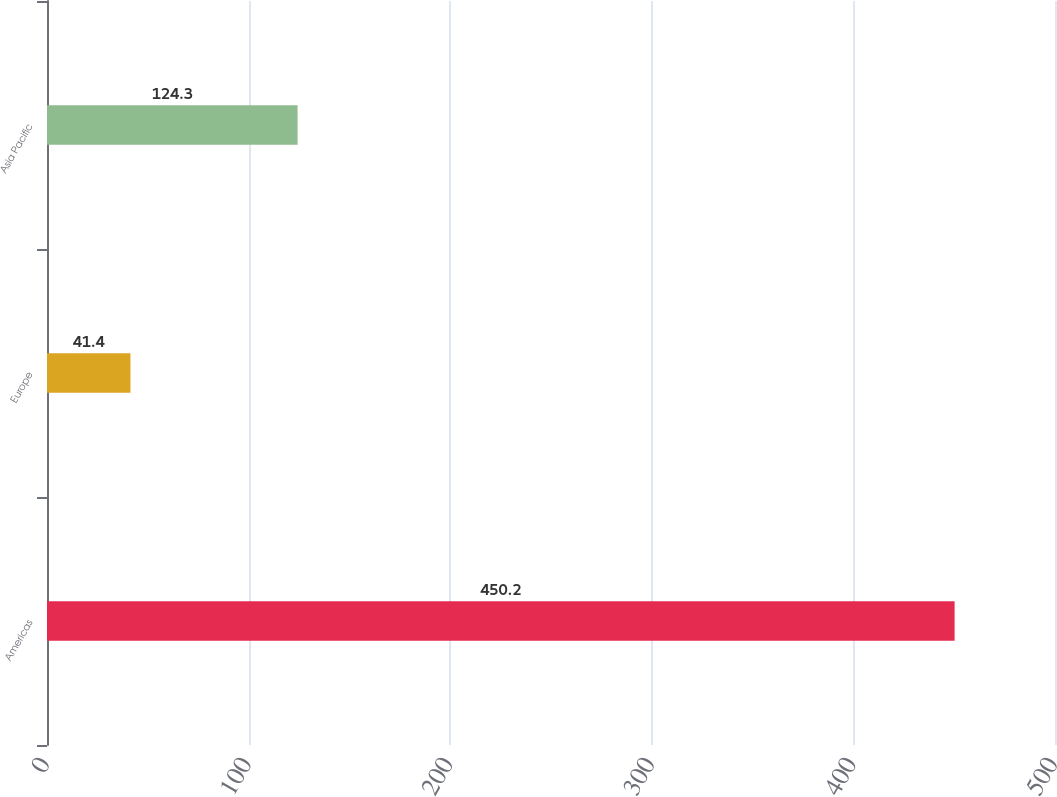<chart> <loc_0><loc_0><loc_500><loc_500><bar_chart><fcel>Americas<fcel>Europe<fcel>Asia Pacific<nl><fcel>450.2<fcel>41.4<fcel>124.3<nl></chart> 